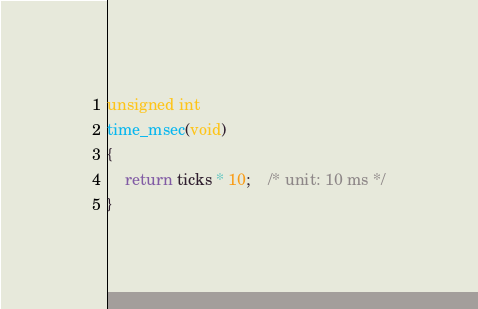Convert code to text. <code><loc_0><loc_0><loc_500><loc_500><_C_>
unsigned int
time_msec(void)
{
	return ticks * 10;	/* unit: 10 ms */
}
</code> 